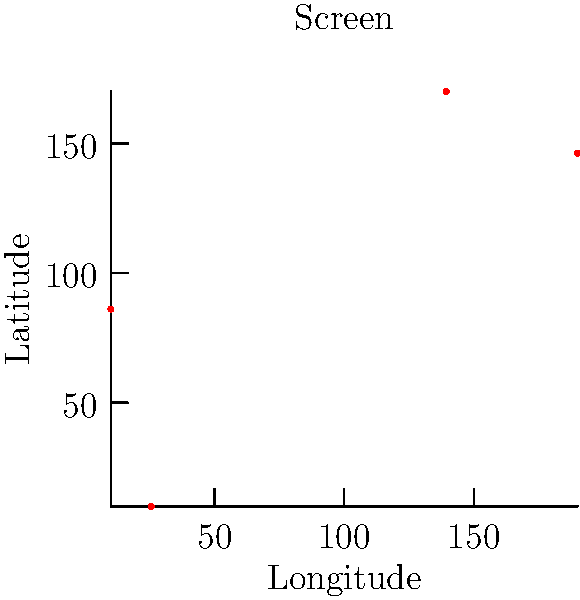You're developing a location-based app using Flutter and need to map geographic coordinates (latitude and longitude) to screen coordinates. Given a screen size of 200x200 pixels and the following set of coordinates:

1. New York: (40.7128, -74.0060)
2. Los Angeles: (34.0522, -118.2437)
3. Chicago: (41.8781, -87.6298)
4. San Francisco: (37.7749, -122.4194)

Calculate the screen coordinates (x, y) for Chicago. Round your answer to the nearest integer. To map geographic coordinates to screen coordinates, we'll follow these steps:

1. Find the minimum and maximum values for latitude and longitude:
   $min_{lat} = 34.0522$, $max_{lat} = 41.8781$
   $min_{lon} = -122.4194$, $max_{lon} = -74.0060$

2. Calculate the range for latitude and longitude:
   $range_{lat} = max_{lat} - min_{lat} = 41.8781 - 34.0522 = 7.8259$
   $range_{lon} = max_{lon} - min_{lon} = -74.0060 - (-122.4194) = 48.4134$

3. Define the screen area for plotting, leaving some margin:
   Width: 180 pixels (10 pixels margin on each side)
   Height: 160 pixels (20 pixels margin on top and bottom)

4. Calculate the scaling factors:
   $scale_x = 180 / range_{lon} = 180 / 48.4134 \approx 3.7179$
   $scale_y = 160 / range_{lat} = 160 / 7.8259 \approx 20.4449$

5. For Chicago (41.8781, -87.6298), calculate the screen coordinates:
   $x = (longitude - min_{lon}) * scale_x + 10$
   $x = (-87.6298 - (-122.4194)) * 3.7179 + 10 \approx 139.4892$

   $y = (latitude - min_{lat}) * scale_y + 10$
   $y = (41.8781 - 34.0522) * 20.4449 + 10 \approx 170.0455$

6. Round the results to the nearest integer:
   $x \approx 139$, $y \approx 170$
Answer: (139, 170) 